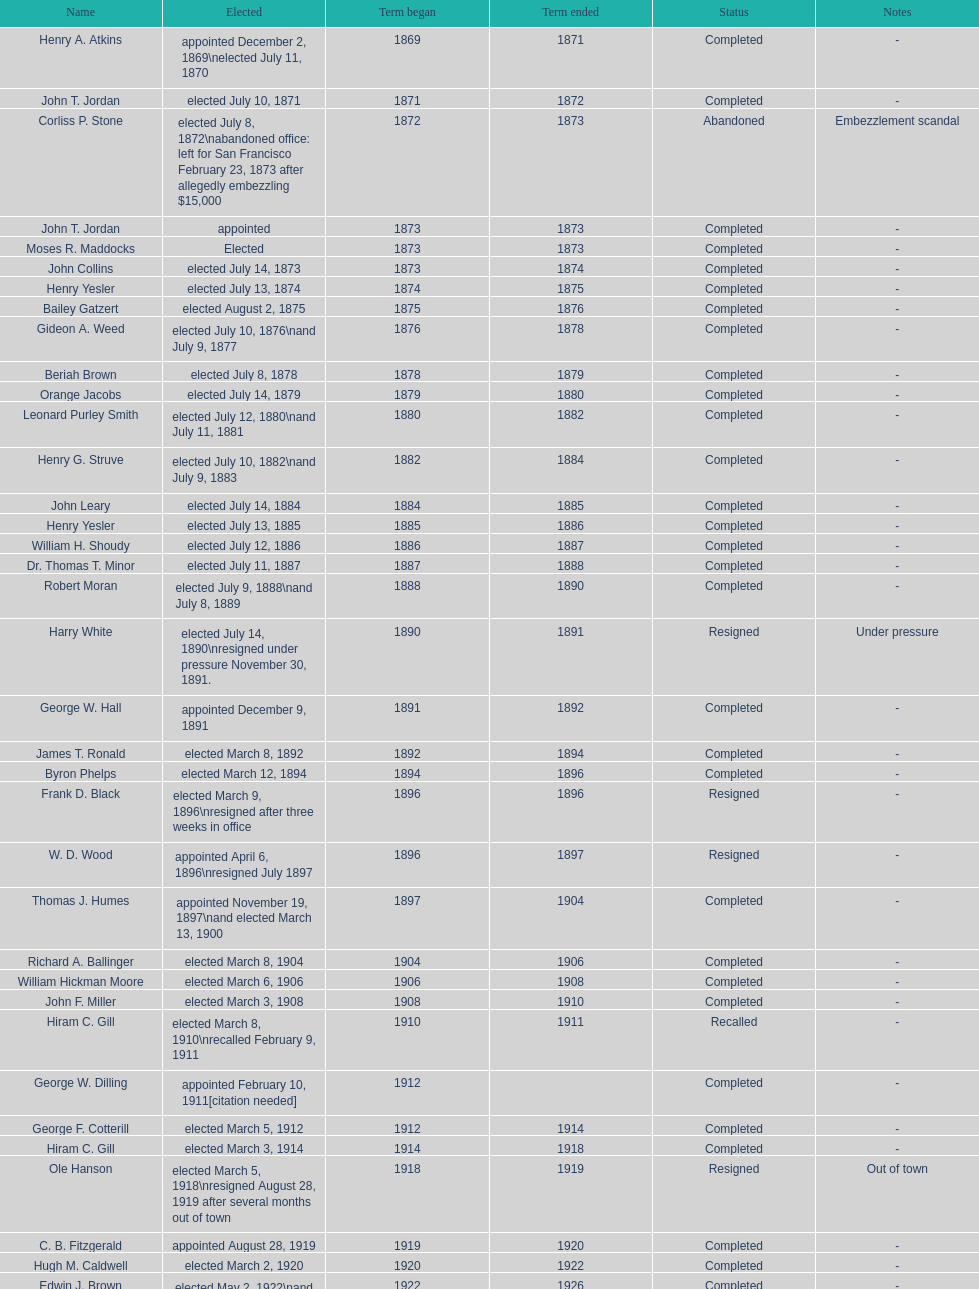How many female individuals have been voted into the mayor's office in seattle, washington? 1. 